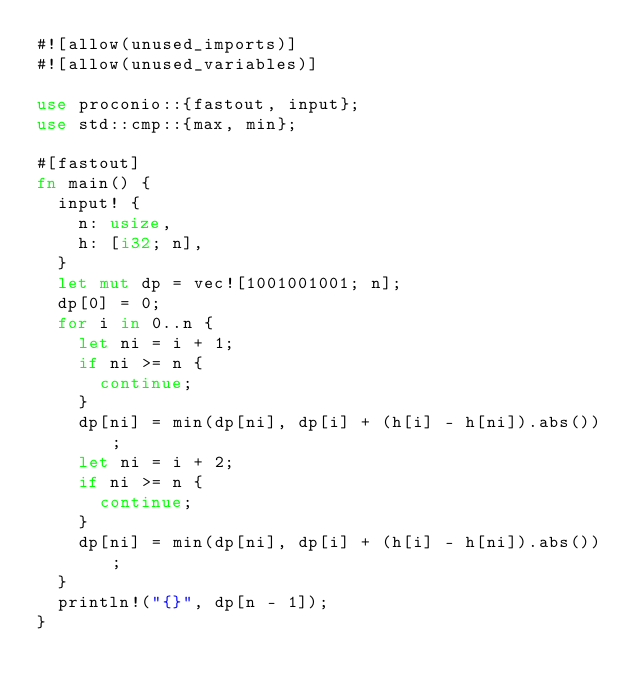Convert code to text. <code><loc_0><loc_0><loc_500><loc_500><_Rust_>#![allow(unused_imports)]
#![allow(unused_variables)]

use proconio::{fastout, input};
use std::cmp::{max, min};

#[fastout]
fn main() {
  input! {
    n: usize,
    h: [i32; n],
  }
  let mut dp = vec![1001001001; n];
  dp[0] = 0;
  for i in 0..n {
    let ni = i + 1;
    if ni >= n {
      continue;
    }
    dp[ni] = min(dp[ni], dp[i] + (h[i] - h[ni]).abs());
    let ni = i + 2;
    if ni >= n {
      continue;
    }
    dp[ni] = min(dp[ni], dp[i] + (h[i] - h[ni]).abs());
  }
  println!("{}", dp[n - 1]);
}
</code> 